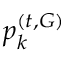<formula> <loc_0><loc_0><loc_500><loc_500>p _ { k } ^ { ( t , G ) }</formula> 